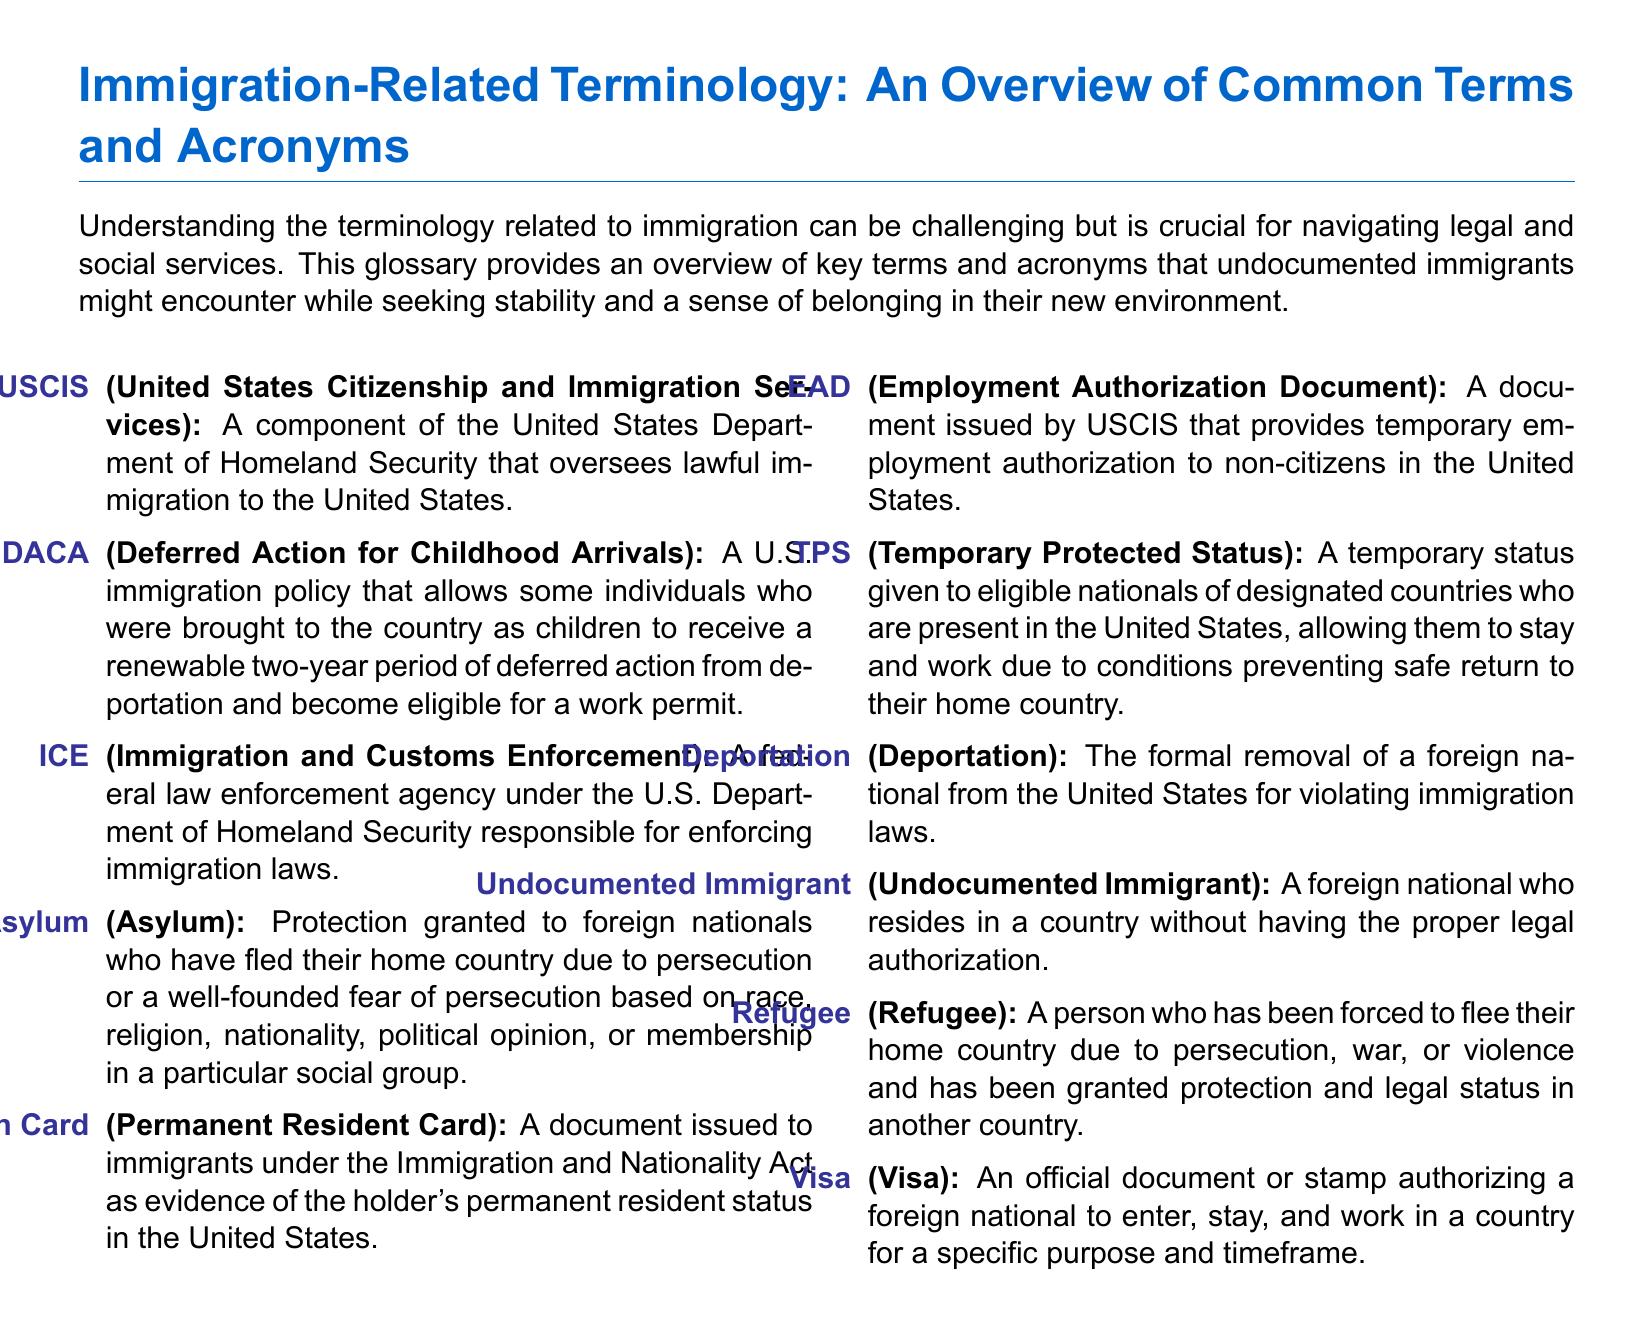What does USCIS stand for? USCIS is an acronym that represents the United States Citizenship and Immigration Services, which is detailed in the document.
Answer: United States Citizenship and Immigration Services What is DACA? DACA is defined in the document as a U.S. immigration policy providing certain individuals with deferred action from deportation.
Answer: Deferred Action for Childhood Arrivals What does ICE do? The document outlines ICE as a federal agency under the Department of Homeland Security responsible for enforcing immigration laws.
Answer: Immigration and Customs Enforcement What is a Green Card? A Green Card is described in the document as a document issued to immigrants as evidence of their permanent resident status.
Answer: Permanent Resident Card What is Temporary Protected Status? The document specifies that TPS is a temporary status given to eligible individuals due to safety concerns in their home country.
Answer: Temporary Protected Status What does EAD stand for? EAD is an acronym mentioned in the document, indicating a specific type of employment authorization document.
Answer: Employment Authorization Document How is a refugee defined? The document states that a refugee is a person who has fled their home country due to persecution or violence.
Answer: Refugee What is the definition of deportation? The document defines deportation as the formal removal of a foreign national from the United States.
Answer: Deportation What is the main purpose of this document? The document aims to provide an overview of common immigration-related terms and acronyms to help individuals navigate legal and social services.
Answer: Glossary of common terms and acronyms 